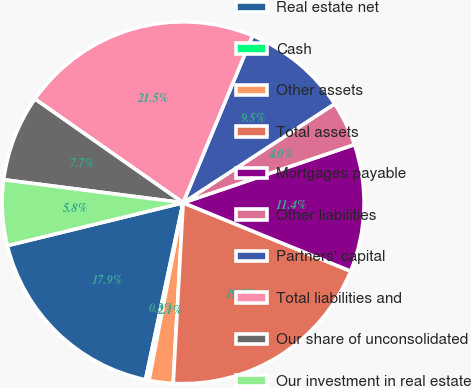<chart> <loc_0><loc_0><loc_500><loc_500><pie_chart><fcel>Real estate net<fcel>Cash<fcel>Other assets<fcel>Total assets<fcel>Mortgages payable<fcel>Other liabilities<fcel>Partners' capital<fcel>Total liabilities and<fcel>Our share of unconsolidated<fcel>Our investment in real estate<nl><fcel>17.86%<fcel>0.31%<fcel>2.15%<fcel>19.71%<fcel>11.38%<fcel>4.0%<fcel>9.53%<fcel>21.55%<fcel>7.69%<fcel>5.84%<nl></chart> 